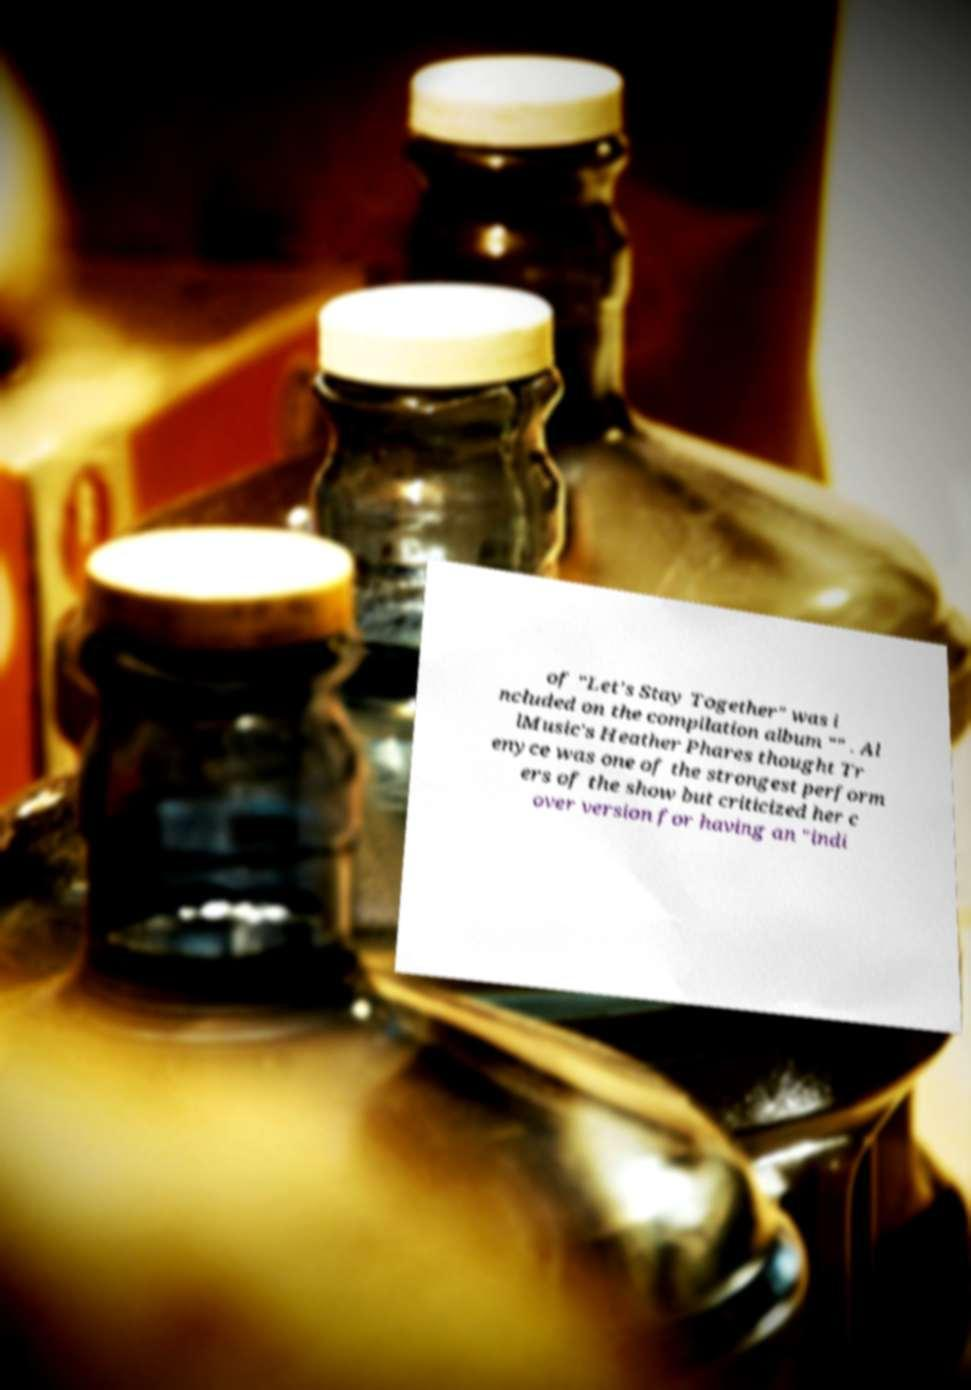I need the written content from this picture converted into text. Can you do that? of "Let's Stay Together" was i ncluded on the compilation album "" . Al lMusic's Heather Phares thought Tr enyce was one of the strongest perform ers of the show but criticized her c over version for having an "indi 